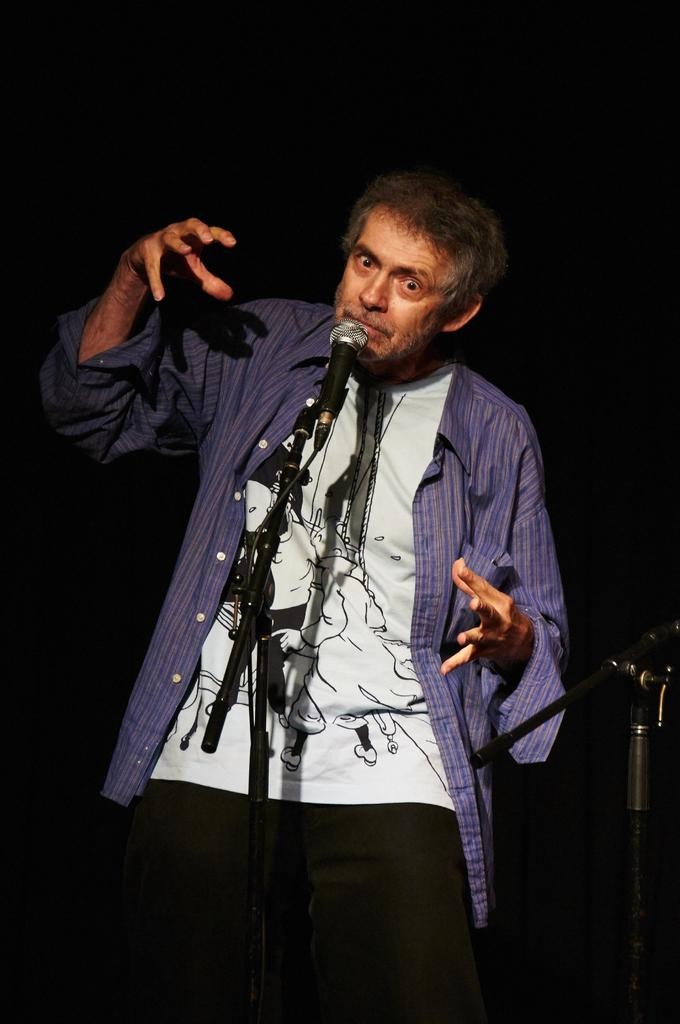What is the main subject of the image? The main subject of the image is a man. What is the man doing in the image? The man is standing in front of a microphone. Can you see any pigs or fish in the image? No, there are no pigs or fish present in the image. Is the man standing in an alley in the image? There is no information about the location or setting of the image, so it cannot be determined if the man is standing in an alley. 